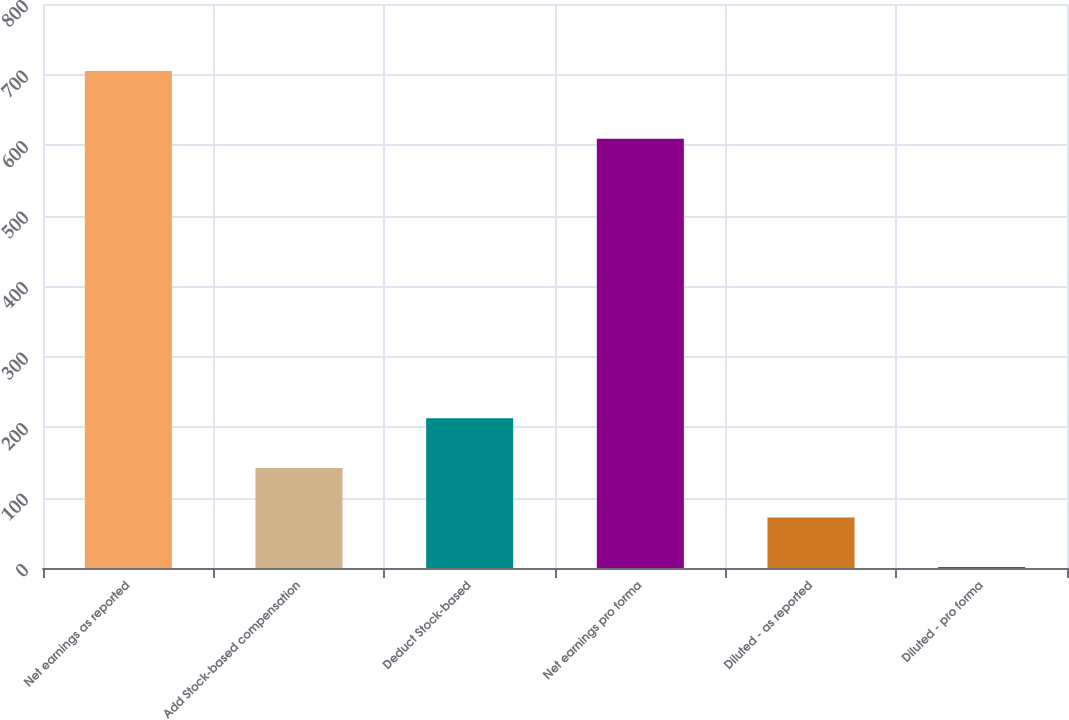<chart> <loc_0><loc_0><loc_500><loc_500><bar_chart><fcel>Net earnings as reported<fcel>Add Stock-based compensation<fcel>Deduct Stock-based<fcel>Net earnings pro forma<fcel>Diluted - as reported<fcel>Diluted - pro forma<nl><fcel>705<fcel>142<fcel>212.38<fcel>609<fcel>71.62<fcel>1.25<nl></chart> 